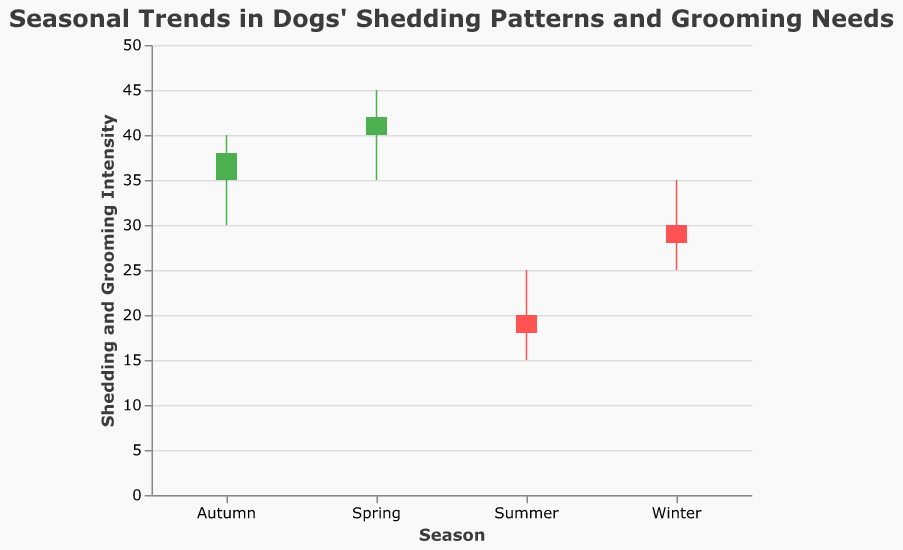what is the title of the chart? The chart title is located at the top of the figure. It provides a descriptive context for what the chart represents, which helps viewers understand the data being visualized.
Answer: Seasonal Trends in Dogs' Shedding Patterns and Grooming Needs Which season shows the highest grooming and shedding intensity? To determine the highest grooming and shedding intensity, observe the "High" values for each season. The season with the highest value is the answer.
Answer: Spring In which season was there a decrease in shedding and grooming intensity from the opening to the close? Compare the "Open" and "Close" values for each season. The season where the "Open" value is higher than the "Close" value indicates a decrease in intensity.
Answer: Winter How does the average grooming volume in Winter compare to that in Autumn? Calculate the average of the values for the "Volume" field in Winter and Autumn, then compare the two averages. For simplicity, compare the raw values as given. Winter's volume is 100, and Autumn's volume is 120, so the volume in Winter is lower.
Answer: Winter's volume is lower than Autumn's What is the difference between the highest intensity in Summer and the highest intensity in Autumn? Subtract the "High" value of Summer from the "High" value of Autumn. For Autumn, it's 40, and for Summer, it's 25. So, 40 - 25 = 15.
Answer: 15 Which season has the smallest range of shedding and grooming intensity? Determine the range by subtracting the "Low" value from the "High" value for each season. Compare the ranges to find the smallest one.
Answer: Winter In which season did the projected shedding and grooming intensity (Open) and the actual (Close) match most closely? Compare the difference between the "Open" and "Close" values for each season. The season with the smallest difference indicates the closest match.
Answer: Autumn Based on the volume, which season suggests the highest grooming needs? The "Volume" field indicates grooming frequency. Identify the season with the highest volume value.
Answer: Summer What is the overall trend in shedding and grooming intensity from Winter to Autumn? Observe the "Close" values for each season in chronological order from Winter to Autumn. The pattern shows an increase in Spring, a decrease in Summer, and then an increase in Autumn.
Answer: Fluctuating with peaks in Spring and Autumn Which season had the most significant decrease in intensity from the high point to low point? Subtract the "Low" value from the "High" value for each season to determine the drop within the season. Identify the season with the largest drop value.
Answer: Summer 